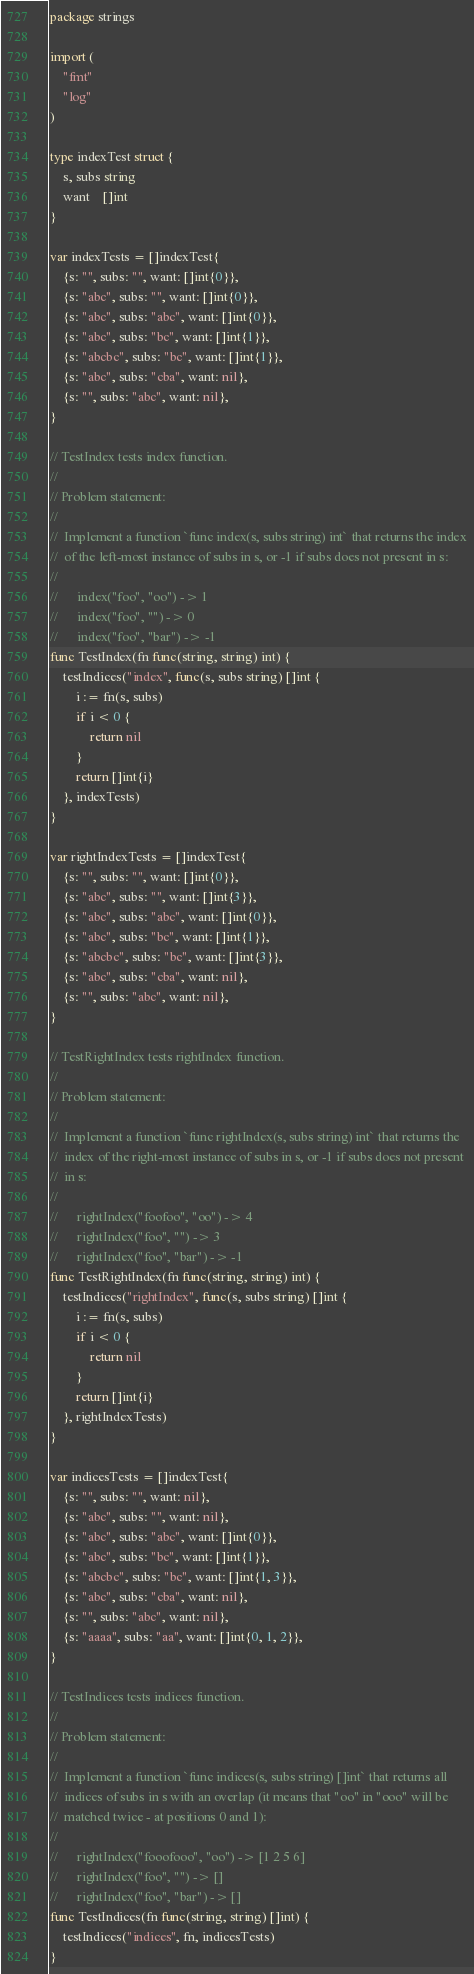<code> <loc_0><loc_0><loc_500><loc_500><_Go_>package strings

import (
	"fmt"
	"log"
)

type indexTest struct {
	s, subs string
	want    []int
}

var indexTests = []indexTest{
	{s: "", subs: "", want: []int{0}},
	{s: "abc", subs: "", want: []int{0}},
	{s: "abc", subs: "abc", want: []int{0}},
	{s: "abc", subs: "bc", want: []int{1}},
	{s: "abcbc", subs: "bc", want: []int{1}},
	{s: "abc", subs: "cba", want: nil},
	{s: "", subs: "abc", want: nil},
}

// TestIndex tests index function.
//
// Problem statement:
//
//	Implement a function `func index(s, subs string) int` that returns the index
//	of the left-most instance of subs in s, or -1 if subs does not present in s:
//
//		index("foo", "oo") -> 1
//		index("foo", "") -> 0
//		index("foo", "bar") -> -1
func TestIndex(fn func(string, string) int) {
	testIndices("index", func(s, subs string) []int {
		i := fn(s, subs)
		if i < 0 {
			return nil
		}
		return []int{i}
	}, indexTests)
}

var rightIndexTests = []indexTest{
	{s: "", subs: "", want: []int{0}},
	{s: "abc", subs: "", want: []int{3}},
	{s: "abc", subs: "abc", want: []int{0}},
	{s: "abc", subs: "bc", want: []int{1}},
	{s: "abcbc", subs: "bc", want: []int{3}},
	{s: "abc", subs: "cba", want: nil},
	{s: "", subs: "abc", want: nil},
}

// TestRightIndex tests rightIndex function.
//
// Problem statement:
//
//	Implement a function `func rightIndex(s, subs string) int` that returns the
//	index of the right-most instance of subs in s, or -1 if subs does not present
//	in s:
//
//		rightIndex("foofoo", "oo") -> 4
//		rightIndex("foo", "") -> 3
//		rightIndex("foo", "bar") -> -1
func TestRightIndex(fn func(string, string) int) {
	testIndices("rightIndex", func(s, subs string) []int {
		i := fn(s, subs)
		if i < 0 {
			return nil
		}
		return []int{i}
	}, rightIndexTests)
}

var indicesTests = []indexTest{
	{s: "", subs: "", want: nil},
	{s: "abc", subs: "", want: nil},
	{s: "abc", subs: "abc", want: []int{0}},
	{s: "abc", subs: "bc", want: []int{1}},
	{s: "abcbc", subs: "bc", want: []int{1, 3}},
	{s: "abc", subs: "cba", want: nil},
	{s: "", subs: "abc", want: nil},
	{s: "aaaa", subs: "aa", want: []int{0, 1, 2}},
}

// TestIndices tests indices function.
//
// Problem statement:
//
//	Implement a function `func indices(s, subs string) []int` that returns all
//	indices of subs in s with an overlap (it means that "oo" in "ooo" will be
//	matched twice - at positions 0 and 1):
//
//		rightIndex("fooofooo", "oo") -> [1 2 5 6]
//		rightIndex("foo", "") -> []
//		rightIndex("foo", "bar") -> []
func TestIndices(fn func(string, string) []int) {
	testIndices("indices", fn, indicesTests)
}
</code> 